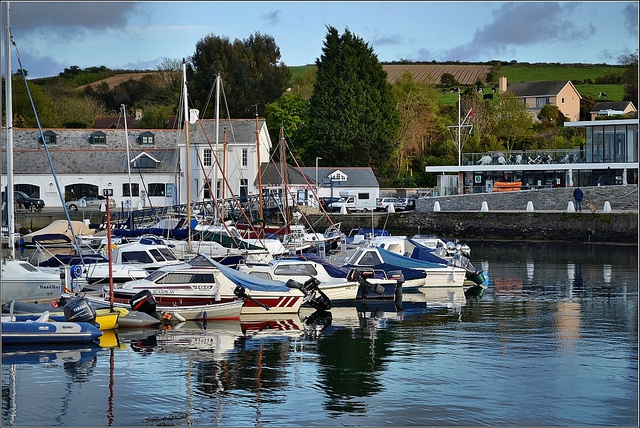Describe the objects in this image and their specific colors. I can see boat in black, darkgray, gray, and lightgray tones, boat in black, lightgray, darkgray, and gray tones, boat in black, gray, darkgray, and lightgray tones, boat in black, gray, navy, and white tones, and boat in black, navy, darkgray, and blue tones in this image. 